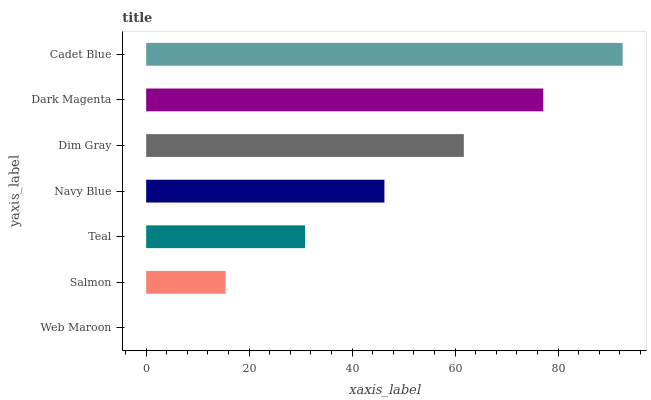Is Web Maroon the minimum?
Answer yes or no. Yes. Is Cadet Blue the maximum?
Answer yes or no. Yes. Is Salmon the minimum?
Answer yes or no. No. Is Salmon the maximum?
Answer yes or no. No. Is Salmon greater than Web Maroon?
Answer yes or no. Yes. Is Web Maroon less than Salmon?
Answer yes or no. Yes. Is Web Maroon greater than Salmon?
Answer yes or no. No. Is Salmon less than Web Maroon?
Answer yes or no. No. Is Navy Blue the high median?
Answer yes or no. Yes. Is Navy Blue the low median?
Answer yes or no. Yes. Is Cadet Blue the high median?
Answer yes or no. No. Is Teal the low median?
Answer yes or no. No. 